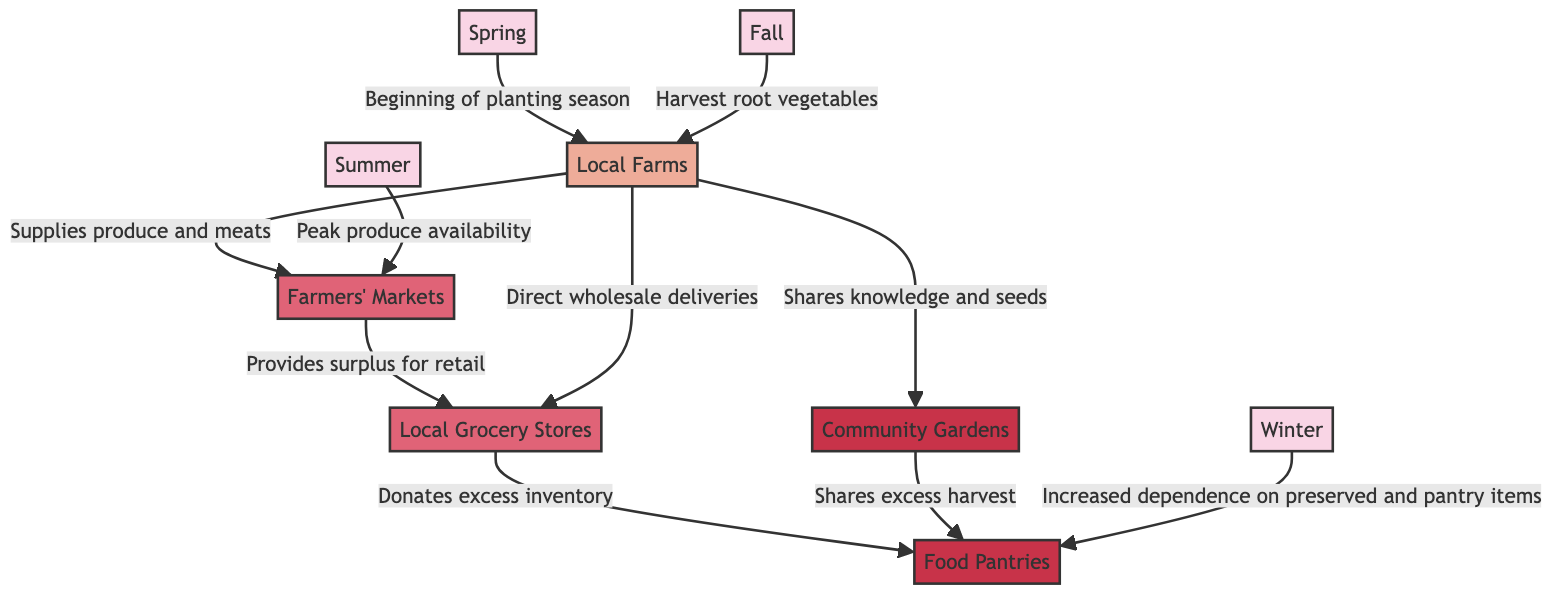What is the role of local farms in winter? In the diagram, local farms supply produce and meats to farmers markets, and during winter, there is an increased dependence on preserved and pantry items coming from food pantries, indicating that farming is less active.
Answer: Increased dependence on preserved items How many seasonal variations are shown in the diagram? The diagram includes four seasonal variations: Winter, Spring, Summer, and Fall. Therefore, by counting these labels, the total number is determined to be four.
Answer: Four What does community gardens share with food pantries? According to the diagram, community gardens share excess harvest with food pantries, indicating a direct relationship between the two.
Answer: Excess harvest Which season represents the peak produce availability? The diagram specifically states that summer represents the peak produce availability, as it is directly connected to the farmers' markets.
Answer: Summer From local farms to local grocery stores, what are the two ways of supply? The diagram indicates that local farms contribute produce and meats to farmers' markets and make direct wholesale deliveries to local grocery stores. Hence, these two methods are identified.
Answer: Supplies produce and direct wholesale deliveries 